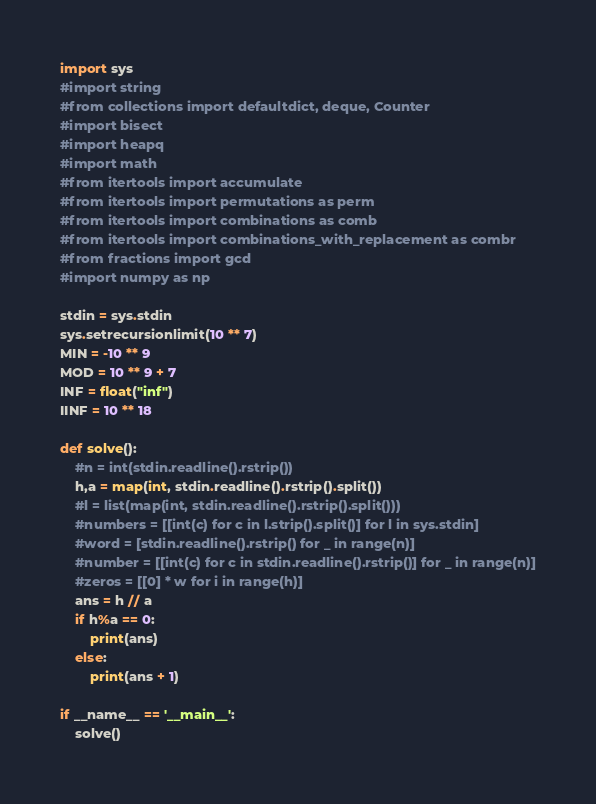Convert code to text. <code><loc_0><loc_0><loc_500><loc_500><_Python_>import sys
#import string
#from collections import defaultdict, deque, Counter
#import bisect
#import heapq
#import math
#from itertools import accumulate
#from itertools import permutations as perm
#from itertools import combinations as comb
#from itertools import combinations_with_replacement as combr
#from fractions import gcd
#import numpy as np

stdin = sys.stdin
sys.setrecursionlimit(10 ** 7)
MIN = -10 ** 9
MOD = 10 ** 9 + 7
INF = float("inf")
IINF = 10 ** 18

def solve():
    #n = int(stdin.readline().rstrip())
    h,a = map(int, stdin.readline().rstrip().split())
    #l = list(map(int, stdin.readline().rstrip().split()))
    #numbers = [[int(c) for c in l.strip().split()] for l in sys.stdin]
    #word = [stdin.readline().rstrip() for _ in range(n)]
    #number = [[int(c) for c in stdin.readline().rstrip()] for _ in range(n)]
    #zeros = [[0] * w for i in range(h)]
    ans = h // a
    if h%a == 0:
        print(ans)
    else:
        print(ans + 1)

if __name__ == '__main__':
    solve()
</code> 